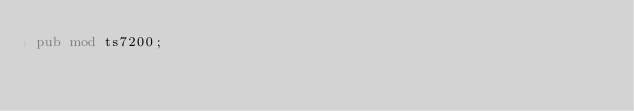Convert code to text. <code><loc_0><loc_0><loc_500><loc_500><_Rust_>pub mod ts7200;
</code> 